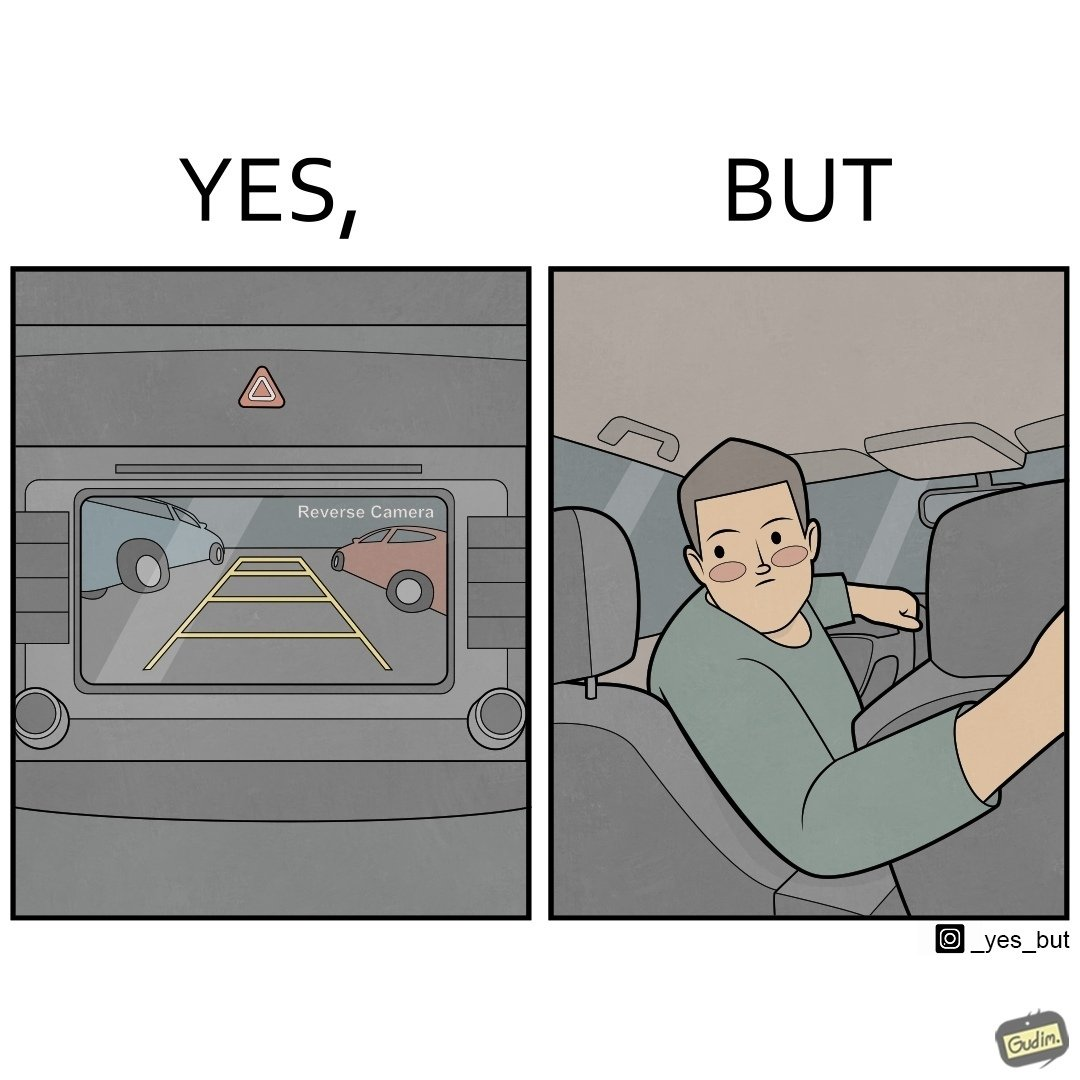Would you classify this image as satirical? Yes, this image is satirical. 